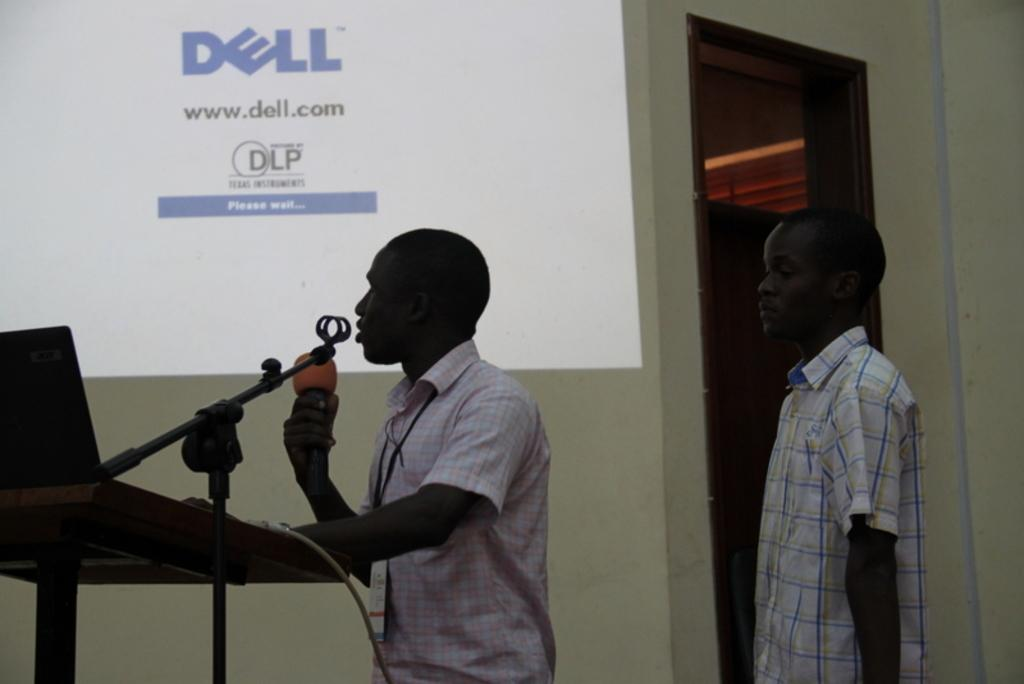What type of structure can be seen in the image? There is a wall in the image. What electronic device is present in the image? There is a screen in the image. How many people are in the image? There are two people standing in the image. What is the person on the left side holding? The person on the left side is holding a mic. What type of treatment is being administered to the person on the right side in the image? There is no treatment being administered in the image; it only shows two people standing with a screen and a wall in the background. 